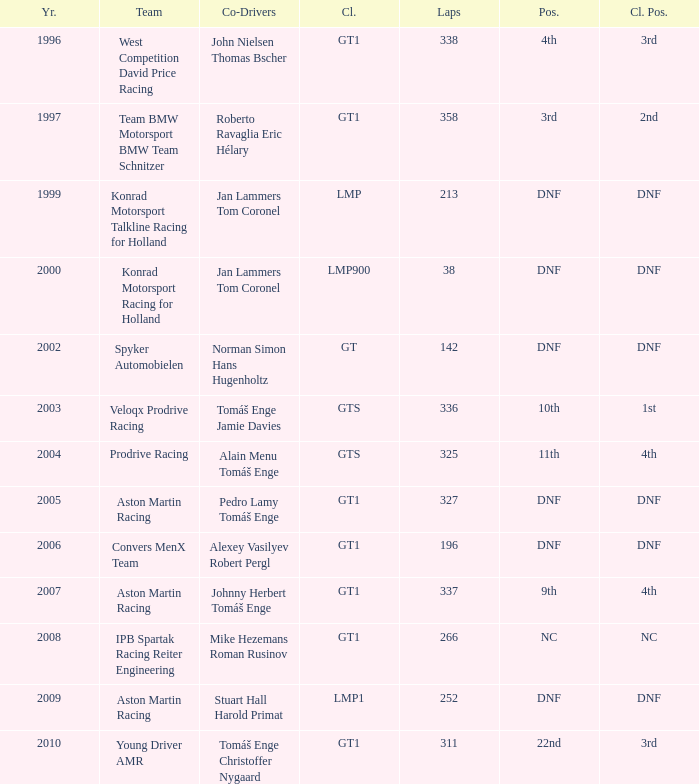Which team achieved a 3rd place finish in their class with 337 laps before the year 2008? West Competition David Price Racing. 